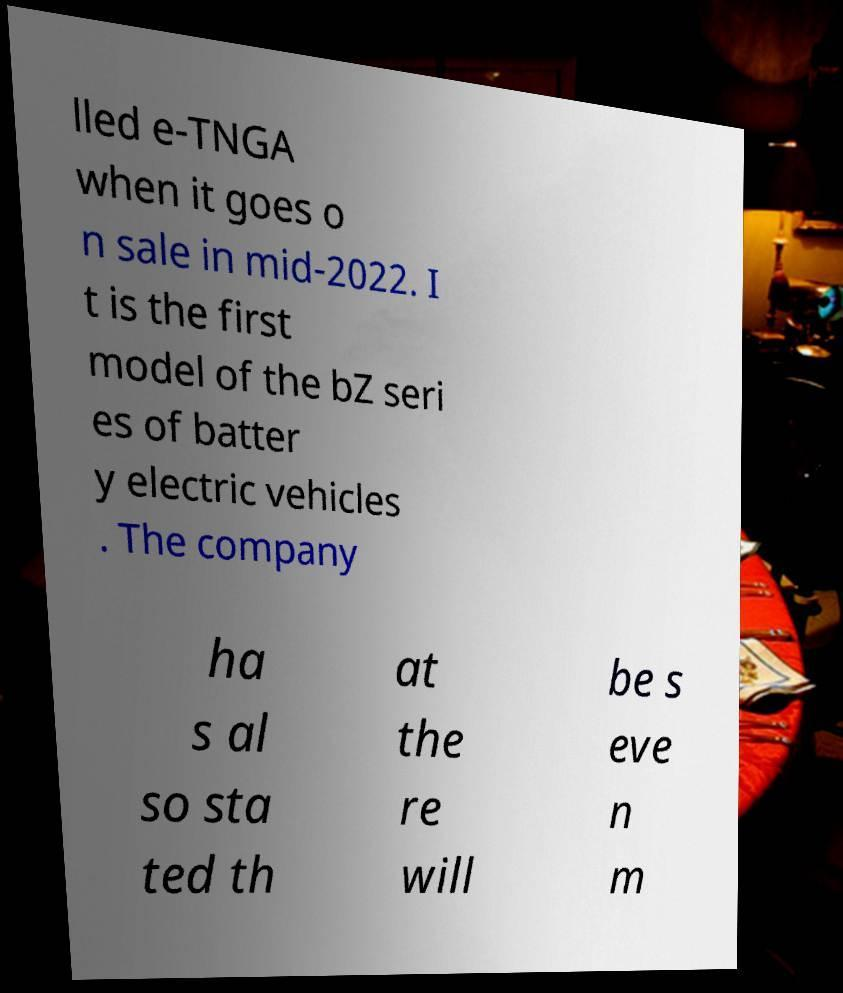For documentation purposes, I need the text within this image transcribed. Could you provide that? lled e-TNGA when it goes o n sale in mid-2022. I t is the first model of the bZ seri es of batter y electric vehicles . The company ha s al so sta ted th at the re will be s eve n m 